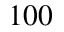<formula> <loc_0><loc_0><loc_500><loc_500>1 0 0</formula> 